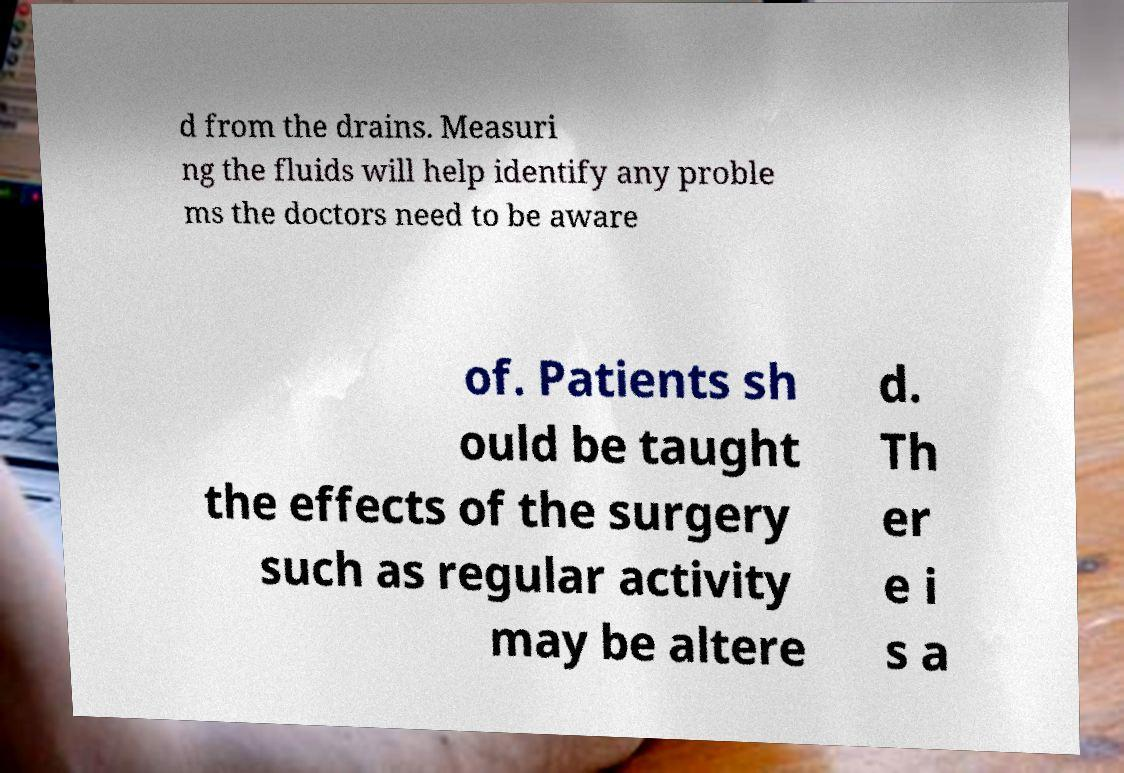Can you read and provide the text displayed in the image?This photo seems to have some interesting text. Can you extract and type it out for me? d from the drains. Measuri ng the fluids will help identify any proble ms the doctors need to be aware of. Patients sh ould be taught the effects of the surgery such as regular activity may be altere d. Th er e i s a 